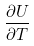Convert formula to latex. <formula><loc_0><loc_0><loc_500><loc_500>\frac { \partial U } { \partial T }</formula> 